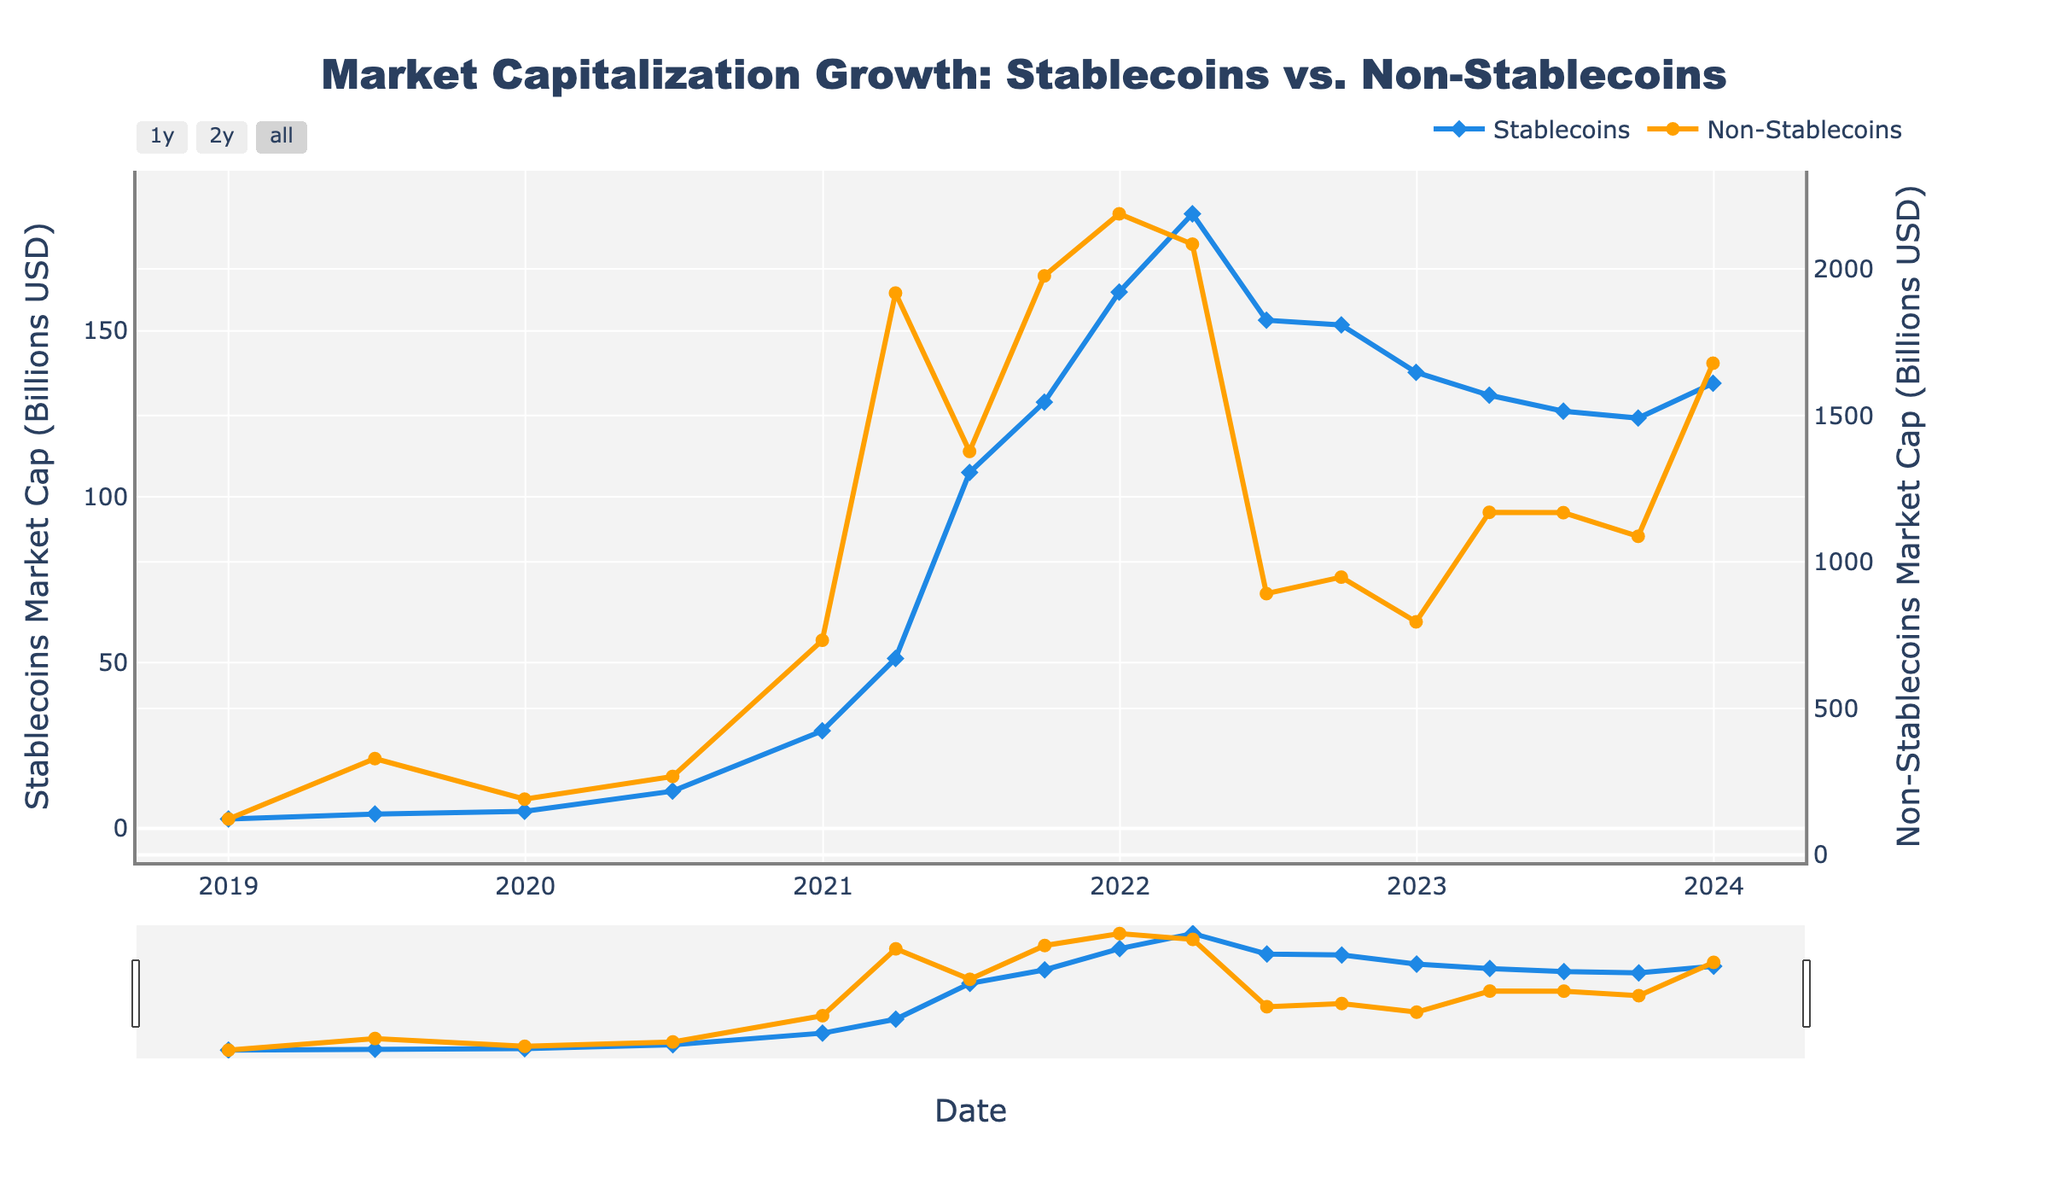What trend do you notice for the market capitalization of stablecoins from 2019 to 2023? By observing the blue line representing stablecoins on the chart, it's evident that there is a steady increase in market capitalization from 2019 to the end of 2021. The value peaks around early 2022 and then gradually declines with some variations.
Answer: Steady increase till early 2022, followed by a decline How did the market capitalizations of stablecoins and non-stablecoins compare at the end of 2021? At the end of 2021, the values are shown on the y-axes where the blue line for stablecoins reaches approximately 161.7 billion USD, and the orange line for non-stablecoins is at approximately 2188.3 billion USD. This clearly shows that the non-stablecoins' market cap is significantly higher than that of the stablecoins.
Answer: Non-stablecoins: 2188.3 billion USD, Stablecoins: 161.7 billion USD Was there any period where the market capitalization of stablecoins decreased significantly? If so, when? Observing the blue line for stablecoins, a significant decrease can be seen between March 2022 and June 2022, where the market capitalization dropped from around 185.3 billion USD to 153.2 billion USD.
Answer: Between March 2022 to June 2022 During which quarter in 2021 did non-stablecoins experience their highest market cap? The orange line indicates the trend of non-stablecoins, which peaks between the first and second quarters of 2021, reaching its highest point at approximately 1976.5 billion USD around Q1 2021.
Answer: Q1 2021 What was the difference between the market capitalization of stablecoins and non-stablecoins in December 2019? Based on the data for December 2019, the market capitalization for stablecoins is approximately 5.1 billion USD and for non-stablecoins is approximately 190.2 billion USD. The difference is 190.2 - 5.1 = 185.1 billion USD.
Answer: 185.1 billion USD Which color and shape are used to represent stablecoins and non-stablecoins? From the visual attributes of the plot, stablecoins are represented by a blue line with diamond markers, and non-stablecoins are represented by an orange line with circle markers.
Answer: Stablecoins: blue with diamonds, Non-stablecoins: orange with circles How did the market capitalization of non-stablecoins in Q3 of 2022 compare with its value at the end of Q1 2022? The market capitalization of non-stablecoins in Q3 2022 is approximately 948.2 billion USD, while at the end of Q1 2022 it is approximately 2084.7 billion USD. So, it decreased by 2084.7 - 948.2 = 1136.5 billion USD.
Answer: Decreased by 1136.5 billion USD Calculate the average market capitalization of stablecoins over the years 2021 and 2022. To find the average, sum up the stablecoins market cap for the quarters in 2021 and 2022, then divide by the number of quarters. (51.2 + 107.3 + 128.5 + 161.7 + 185.3 + 153.2 + 151.8 + 137.5) / 8 = 147.06 billion USD.
Answer: 147.06 billion USD Identify two quarters where the market cap growth for non-stablecoins saw the sharpest decline. Inspecting the orange line visually, the sharpest declines occur between two consecutive points. The periods where the declines are most pronounced are Q1 2022 to Q2 2022 and Q3 2021 to Q4 2021.
Answer: Q1 2022 to Q2 2022, Q3 2021 to Q4 2021 Which category, stablecoins or non-stablecoins, showed greater stability in their market capitalization over 2023? Observing the trends in 2023, the stablecoins' market capitalization shows a relatively smaller variance with values close to 130.6 billion USD, 125.8 billion USD, and 123.7 billion USD. Non-stablecoins display larger fluctuations with values around 1169.4 billion USD, 1168.2 billion USD, and 1087.5 billion USD, indicating more instability. Thus, stablecoins were more stable.
Answer: Stablecoins 